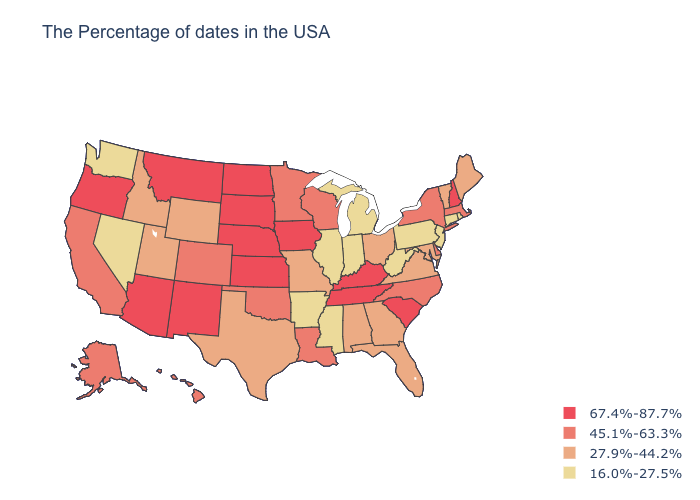Which states have the lowest value in the South?
Concise answer only. West Virginia, Mississippi, Arkansas. What is the value of Texas?
Write a very short answer. 27.9%-44.2%. Does the map have missing data?
Answer briefly. No. Does Arkansas have the lowest value in the South?
Write a very short answer. Yes. Does the first symbol in the legend represent the smallest category?
Concise answer only. No. Name the states that have a value in the range 16.0%-27.5%?
Quick response, please. Rhode Island, Connecticut, New Jersey, Pennsylvania, West Virginia, Michigan, Indiana, Illinois, Mississippi, Arkansas, Nevada, Washington. Name the states that have a value in the range 67.4%-87.7%?
Quick response, please. New Hampshire, South Carolina, Kentucky, Tennessee, Iowa, Kansas, Nebraska, South Dakota, North Dakota, New Mexico, Montana, Arizona, Oregon. What is the highest value in the USA?
Short answer required. 67.4%-87.7%. What is the value of Louisiana?
Keep it brief. 45.1%-63.3%. How many symbols are there in the legend?
Concise answer only. 4. Does the map have missing data?
Write a very short answer. No. What is the highest value in states that border Idaho?
Write a very short answer. 67.4%-87.7%. What is the value of Missouri?
Quick response, please. 27.9%-44.2%. What is the value of Massachusetts?
Concise answer only. 45.1%-63.3%. Name the states that have a value in the range 16.0%-27.5%?
Concise answer only. Rhode Island, Connecticut, New Jersey, Pennsylvania, West Virginia, Michigan, Indiana, Illinois, Mississippi, Arkansas, Nevada, Washington. 